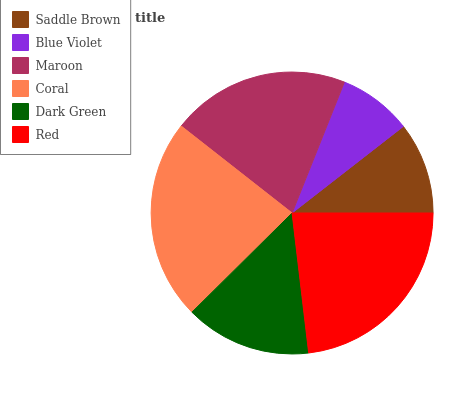Is Blue Violet the minimum?
Answer yes or no. Yes. Is Red the maximum?
Answer yes or no. Yes. Is Maroon the minimum?
Answer yes or no. No. Is Maroon the maximum?
Answer yes or no. No. Is Maroon greater than Blue Violet?
Answer yes or no. Yes. Is Blue Violet less than Maroon?
Answer yes or no. Yes. Is Blue Violet greater than Maroon?
Answer yes or no. No. Is Maroon less than Blue Violet?
Answer yes or no. No. Is Maroon the high median?
Answer yes or no. Yes. Is Dark Green the low median?
Answer yes or no. Yes. Is Blue Violet the high median?
Answer yes or no. No. Is Red the low median?
Answer yes or no. No. 